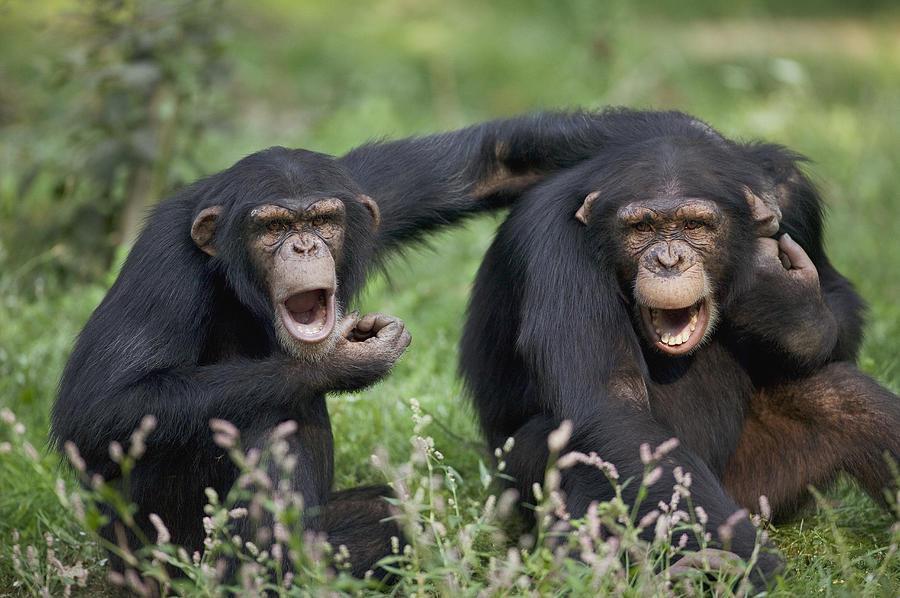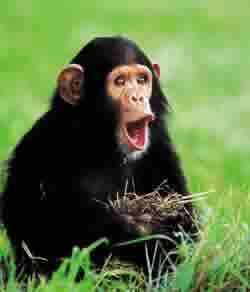The first image is the image on the left, the second image is the image on the right. Assess this claim about the two images: "In one image there is a lone monkey with an open mouth like it is howling.". Correct or not? Answer yes or no. Yes. The first image is the image on the left, the second image is the image on the right. Evaluate the accuracy of this statement regarding the images: "in the right image a chimp is making an O with it's mouth". Is it true? Answer yes or no. Yes. 